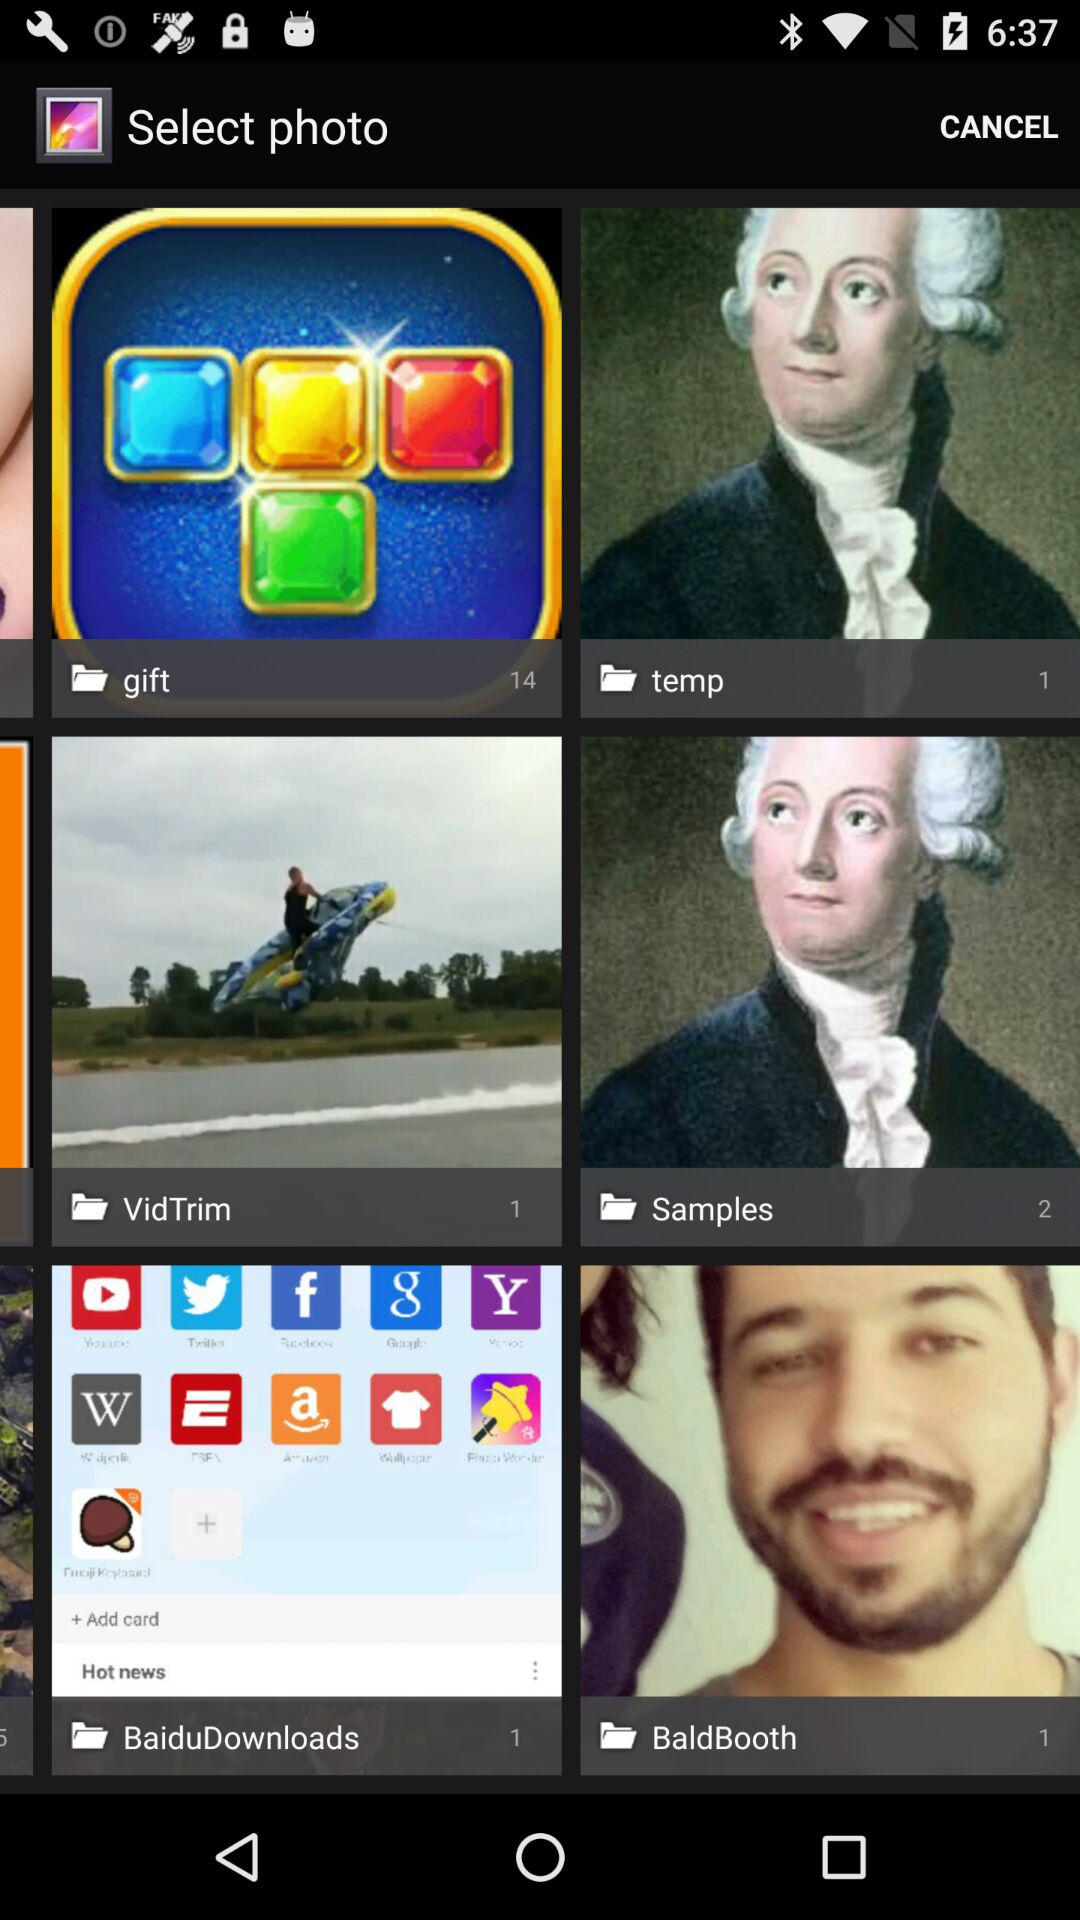How many photos are there in the "temp" folder? There is 1 photo in the "temp" folder. 